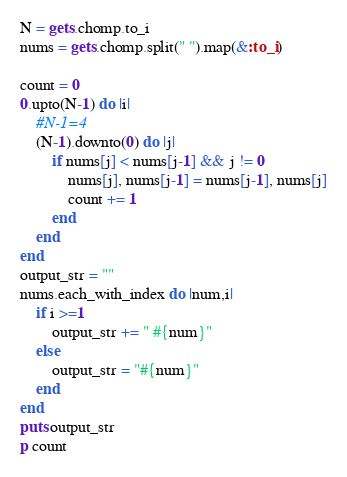Convert code to text. <code><loc_0><loc_0><loc_500><loc_500><_Ruby_>N = gets.chomp.to_i
nums = gets.chomp.split(" ").map(&:to_i)

count = 0
0.upto(N-1) do |i|
    #N-1=4
    (N-1).downto(0) do |j|
        if nums[j] < nums[j-1] && j != 0
            nums[j], nums[j-1] = nums[j-1], nums[j]
            count += 1
        end
    end
end
output_str = ""
nums.each_with_index do |num,i|
    if i >=1
        output_str += " #{num}"
    else
        output_str = "#{num}"
    end
end
puts output_str
p count

</code> 